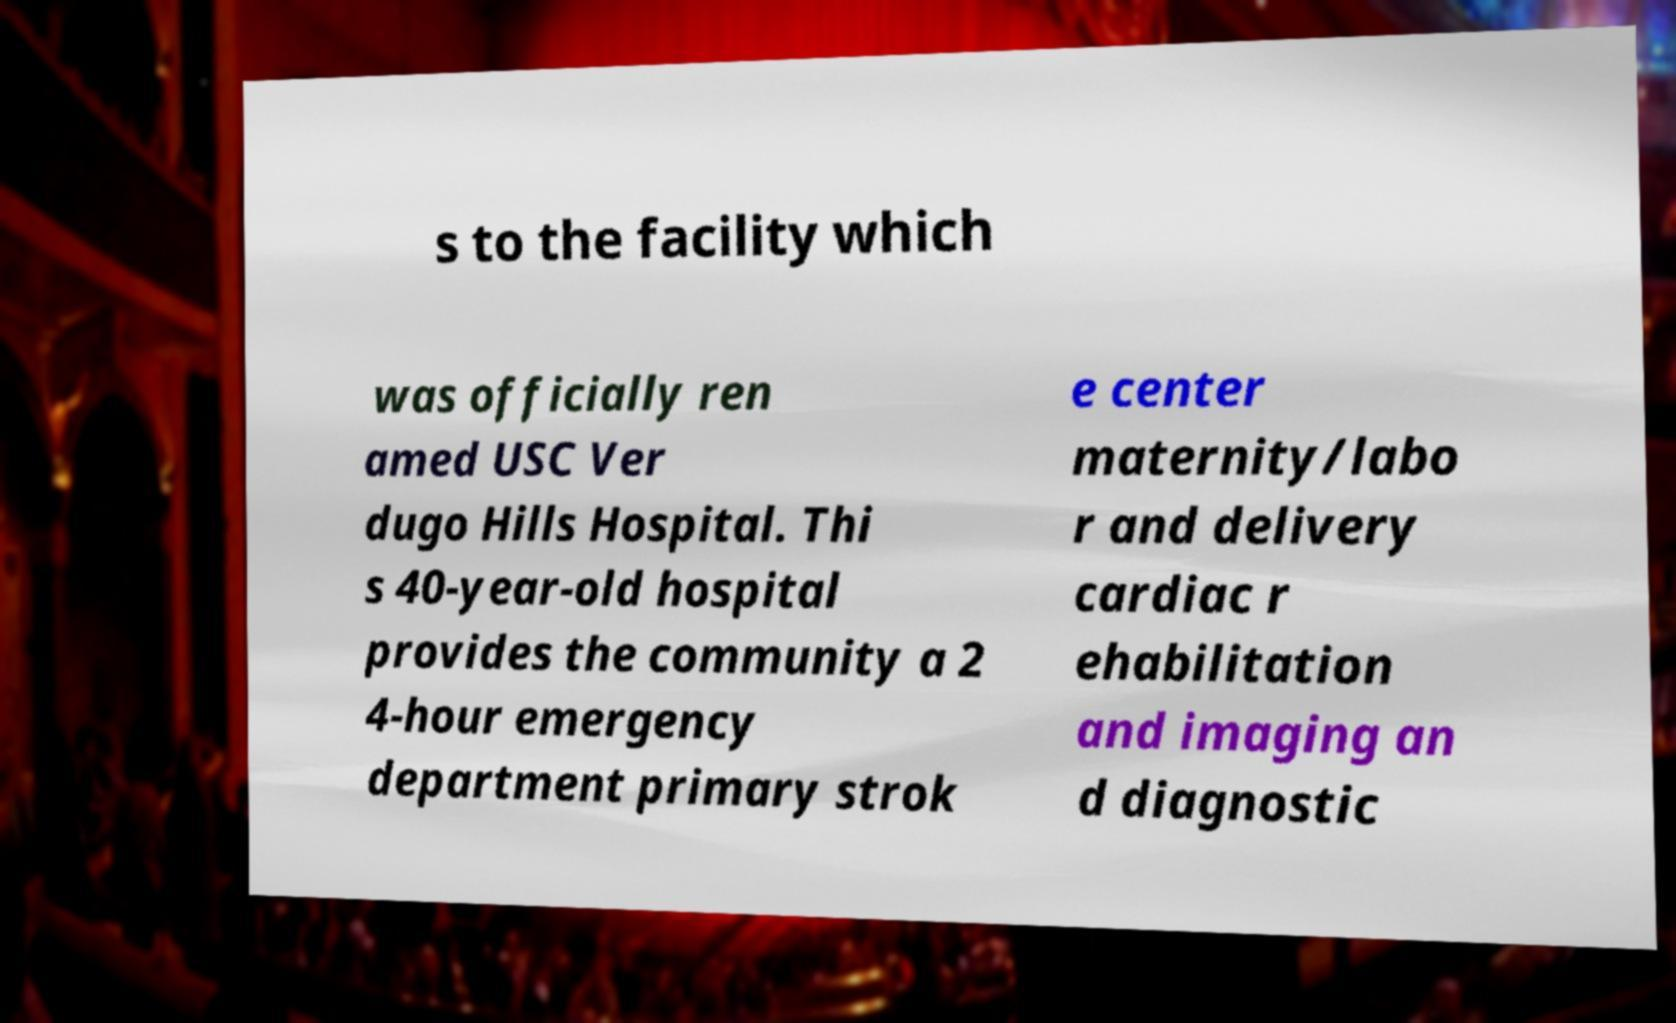I need the written content from this picture converted into text. Can you do that? s to the facility which was officially ren amed USC Ver dugo Hills Hospital. Thi s 40-year-old hospital provides the community a 2 4-hour emergency department primary strok e center maternity/labo r and delivery cardiac r ehabilitation and imaging an d diagnostic 